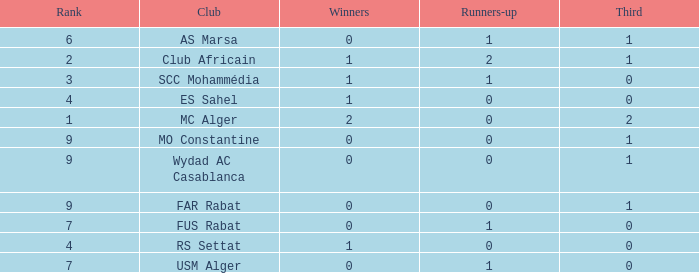Which Winners is the highest one that has a Rank larger than 7, and a Third smaller than 1? None. 